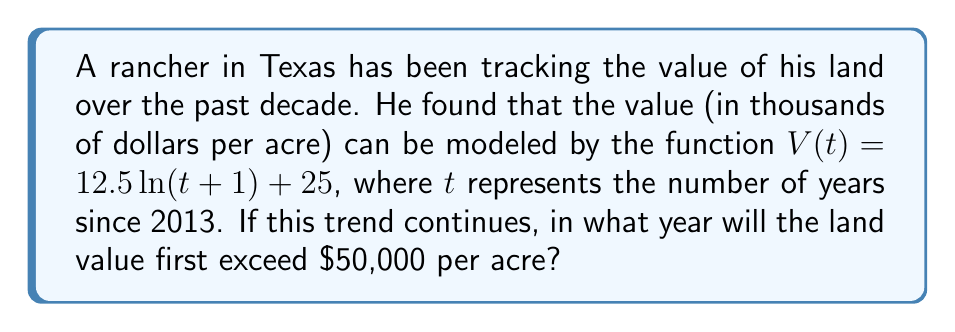Solve this math problem. Let's approach this step-by-step:

1) We need to solve the equation:
   $12.5 \ln(t+1) + 25 = 50$

2) Subtract 25 from both sides:
   $12.5 \ln(t+1) = 25$

3) Divide both sides by 12.5:
   $\ln(t+1) = 2$

4) Apply $e^x$ to both sides:
   $e^{\ln(t+1)} = e^2$

5) Simplify:
   $t + 1 = e^2$

6) Subtract 1 from both sides:
   $t = e^2 - 1$

7) Calculate $e^2$:
   $t \approx 6.389$

8) Since $t$ represents the number of years since 2013, we need to add this to 2013:
   $2013 + 6.389 \approx 2019.389$

9) As we're looking for the first year it exceeds $50,000, we round up to 2020.
Answer: 2020 